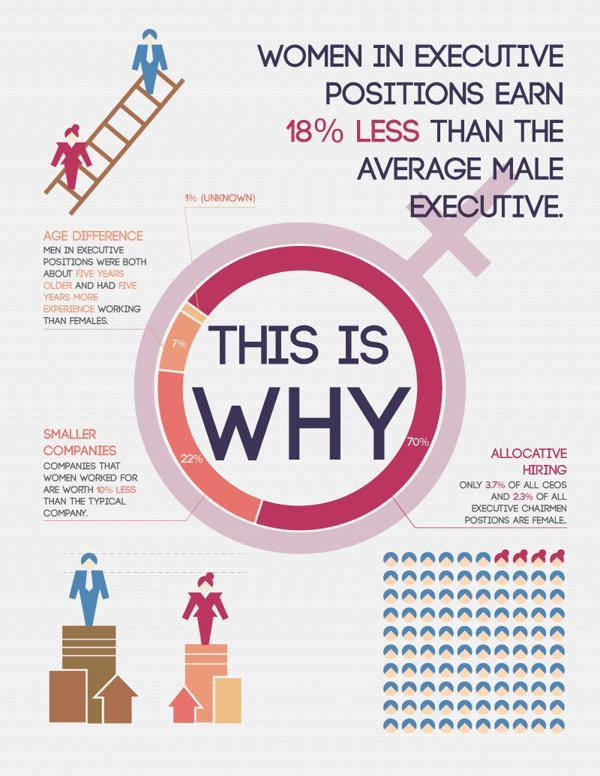What % of all CEOs are males
Answer the question with a short phrase. 63 Which gender in executive positions were more aged and had more experience men How much more in % is the salary of an average male executive  that a female executive 18% what is the suit colour of the male executive, blue or pink blue What % of all executive chairman positions are males 77 